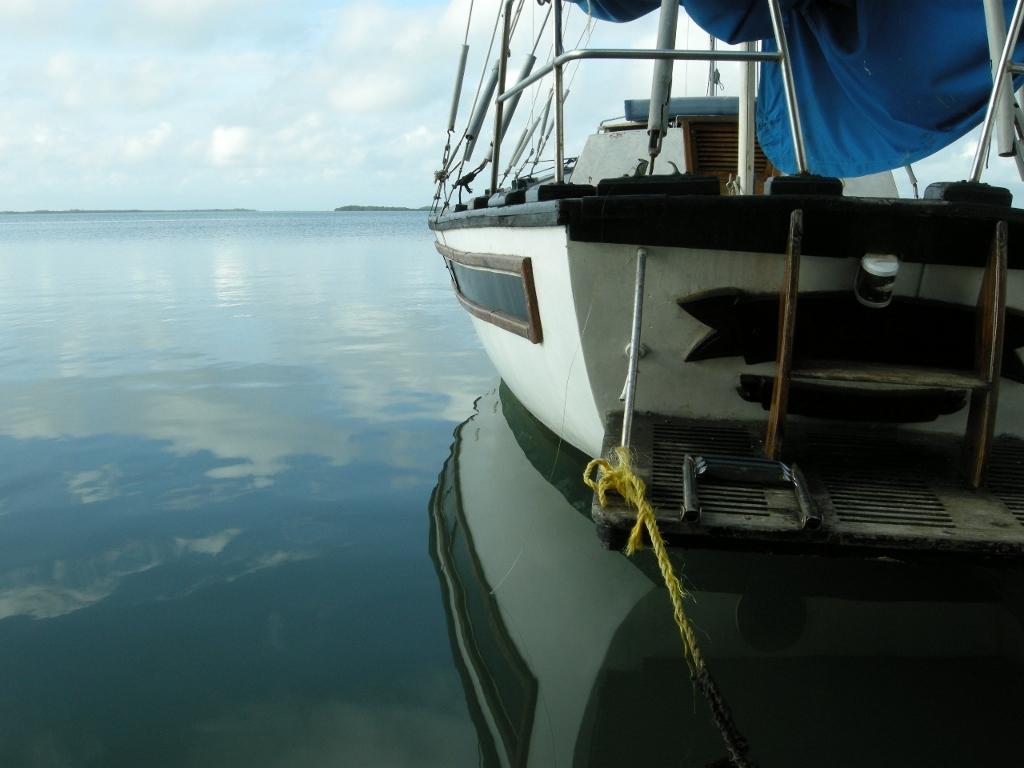In one or two sentences, can you explain what this image depicts? In the picture we can see a boat which is white in color with some black border to it and on it we can see some rods and railing and the boat is tied with yellow color rope which is in the water and in the background we can see a sky and clouds. 